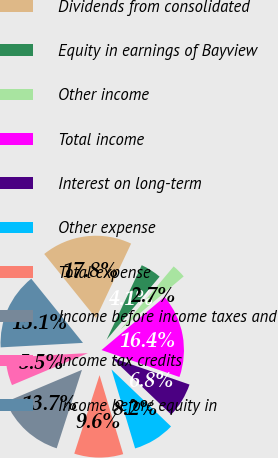Convert chart. <chart><loc_0><loc_0><loc_500><loc_500><pie_chart><fcel>Dividends from consolidated<fcel>Equity in earnings of Bayview<fcel>Other income<fcel>Total income<fcel>Interest on long-term<fcel>Other expense<fcel>Total expense<fcel>Income before income taxes and<fcel>Income tax credits<fcel>Income before equity in<nl><fcel>17.81%<fcel>4.11%<fcel>2.74%<fcel>16.44%<fcel>6.85%<fcel>8.22%<fcel>9.59%<fcel>13.7%<fcel>5.48%<fcel>15.07%<nl></chart> 